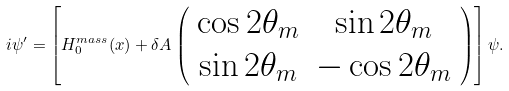<formula> <loc_0><loc_0><loc_500><loc_500>i \psi ^ { \prime } = \left [ H _ { 0 } ^ { m a s s } ( x ) + \delta A \left ( \begin{array} { c c } \cos 2 \theta _ { m } & \sin 2 \theta _ { m } \\ \sin 2 \theta _ { m } & - \cos 2 \theta _ { m } \end{array} \right ) \right ] \psi .</formula> 